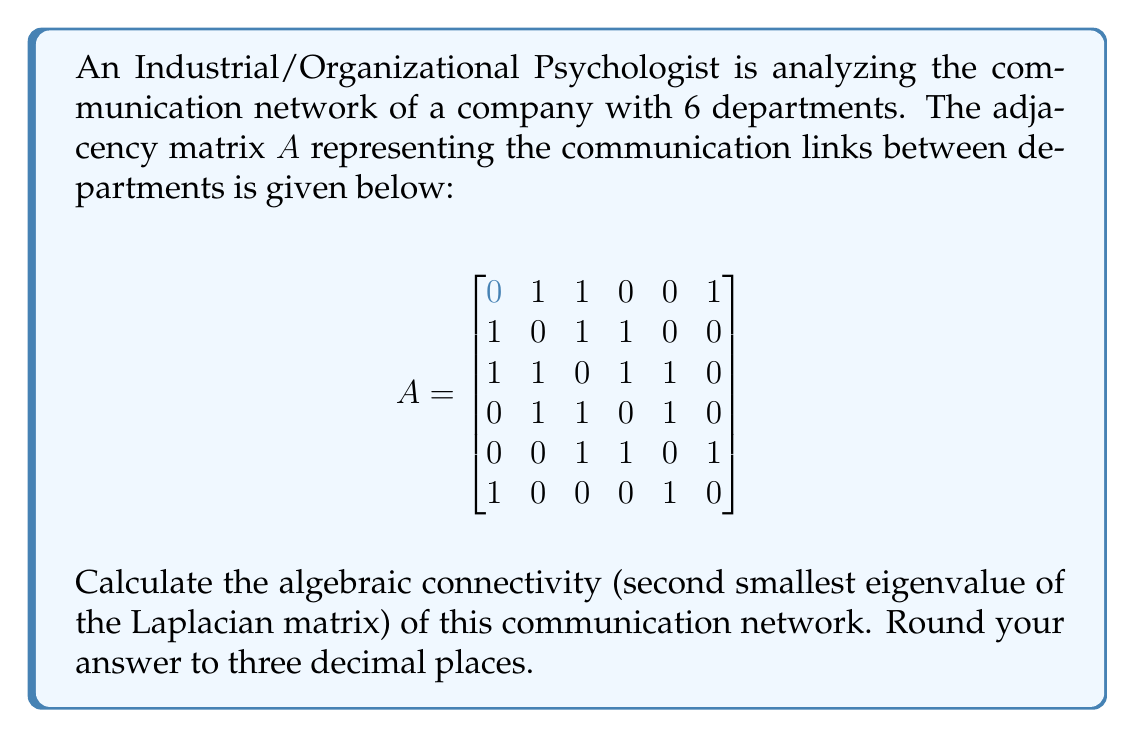Can you solve this math problem? To solve this problem, we'll follow these steps:

1) First, we need to calculate the Laplacian matrix L. The Laplacian matrix is defined as L = D - A, where D is the degree matrix and A is the adjacency matrix.

2) The degree matrix D is a diagonal matrix where each entry $d_{ii}$ is the degree of vertex i:

$$D = \begin{bmatrix}
3 & 0 & 0 & 0 & 0 & 0 \\
0 & 3 & 0 & 0 & 0 & 0 \\
0 & 0 & 4 & 0 & 0 & 0 \\
0 & 0 & 0 & 3 & 0 & 0 \\
0 & 0 & 0 & 0 & 3 & 0 \\
0 & 0 & 0 & 0 & 0 & 2
\end{bmatrix}$$

3) Now we can calculate L = D - A:

$$L = \begin{bmatrix}
3 & -1 & -1 & 0 & 0 & -1 \\
-1 & 3 & -1 & -1 & 0 & 0 \\
-1 & -1 & 4 & -1 & -1 & 0 \\
0 & -1 & -1 & 3 & -1 & 0 \\
0 & 0 & -1 & -1 & 3 & -1 \\
-1 & 0 & 0 & 0 & -1 & 2
\end{bmatrix}$$

4) We need to find the eigenvalues of L. This can be done using numerical methods or computer algebra systems. The eigenvalues are approximately:

   0, 0.7639, 2.0000, 3.0000, 4.2361, 5.0000

5) The algebraic connectivity is the second smallest eigenvalue, which is 0.7639.

6) Rounding to three decimal places gives 0.764.
Answer: 0.764 